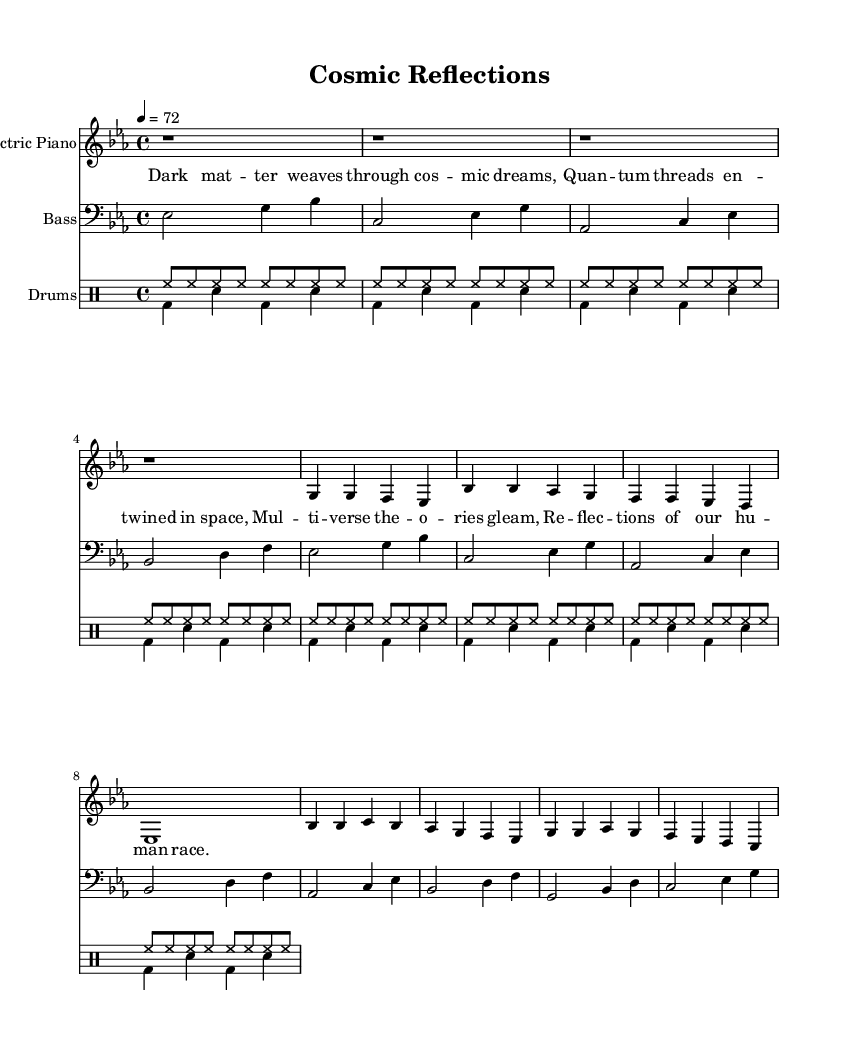What is the key signature of this music? The key signature is E flat major, which has three flat notes: B flat, E flat, and A flat. This is determined by looking at the key signature indicated at the beginning of the score.
Answer: E flat major What is the time signature of this piece? The time signature is 4/4, which means there are four beats in every measure and the quarter note gets one beat. This is found right after the key signature at the beginning of the composition.
Answer: 4/4 What is the tempo marking for this music? The tempo marking is 72 beats per minute, which is indicated at the beginning of the sheet music. This tells the musicians how fast the piece should be played.
Answer: 72 How many measures are there in the verse section? The verse section contains eight measures, which can be counted from the music notation that outlines the verse and repeats it.
Answer: Eight Which instrument has the melody in the introduction? The electric piano has the melody in the introduction as it is notated first and carries the main melodic lines throughout the piece.
Answer: Electric piano What characteristic rhythmic element is typical for Funk music present in the drums? The drums feature a syncopated backbeat, which is a defining trait of Funk music. This can be identified by the accentuated snare hits on the backbeat of the rhythm pattern.
Answer: Syncopated backbeat What type of lyrical theme does this piece explore? The lyrical theme explores existential reflections on the cosmos and our place within it, which is explicitly conveyed through the lyrics that reference quantum threads and the multiverse.
Answer: Cosmic reflections 